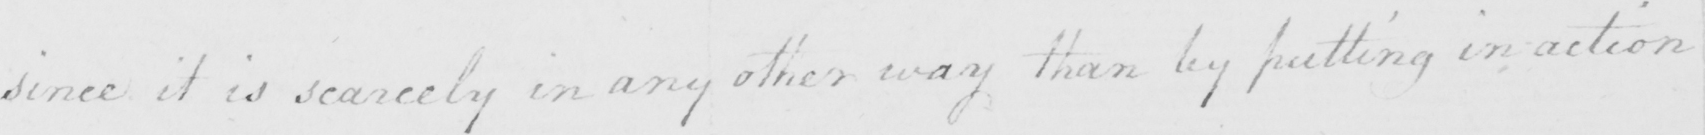What does this handwritten line say? since it is scarcely in any other way than by putting in action 